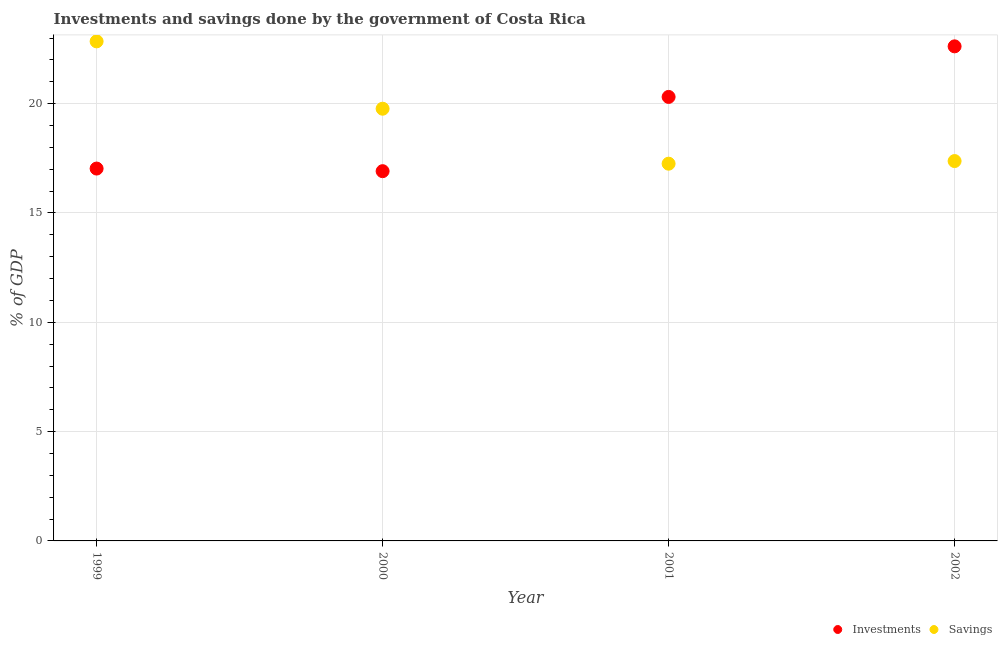How many different coloured dotlines are there?
Your response must be concise. 2. What is the investments of government in 2001?
Your answer should be very brief. 20.31. Across all years, what is the maximum investments of government?
Make the answer very short. 22.62. Across all years, what is the minimum savings of government?
Offer a very short reply. 17.25. In which year was the savings of government maximum?
Provide a short and direct response. 1999. In which year was the investments of government minimum?
Your answer should be very brief. 2000. What is the total investments of government in the graph?
Offer a very short reply. 76.87. What is the difference between the investments of government in 2000 and that in 2002?
Keep it short and to the point. -5.71. What is the difference between the investments of government in 2002 and the savings of government in 2000?
Offer a terse response. 2.85. What is the average investments of government per year?
Provide a short and direct response. 19.22. In the year 2001, what is the difference between the investments of government and savings of government?
Your response must be concise. 3.05. What is the ratio of the savings of government in 1999 to that in 2002?
Provide a short and direct response. 1.32. Is the difference between the investments of government in 1999 and 2001 greater than the difference between the savings of government in 1999 and 2001?
Your response must be concise. No. What is the difference between the highest and the second highest investments of government?
Offer a terse response. 2.31. What is the difference between the highest and the lowest savings of government?
Provide a short and direct response. 5.6. In how many years, is the savings of government greater than the average savings of government taken over all years?
Make the answer very short. 2. Is the sum of the investments of government in 1999 and 2002 greater than the maximum savings of government across all years?
Keep it short and to the point. Yes. Is the savings of government strictly greater than the investments of government over the years?
Provide a short and direct response. No. Is the savings of government strictly less than the investments of government over the years?
Your response must be concise. No. How many years are there in the graph?
Ensure brevity in your answer.  4. What is the difference between two consecutive major ticks on the Y-axis?
Your answer should be very brief. 5. Does the graph contain any zero values?
Your answer should be very brief. No. Does the graph contain grids?
Offer a very short reply. Yes. What is the title of the graph?
Offer a very short reply. Investments and savings done by the government of Costa Rica. Does "Nonresident" appear as one of the legend labels in the graph?
Give a very brief answer. No. What is the label or title of the Y-axis?
Provide a short and direct response. % of GDP. What is the % of GDP of Investments in 1999?
Offer a very short reply. 17.03. What is the % of GDP in Savings in 1999?
Offer a very short reply. 22.85. What is the % of GDP in Investments in 2000?
Provide a short and direct response. 16.91. What is the % of GDP in Savings in 2000?
Your response must be concise. 19.77. What is the % of GDP of Investments in 2001?
Offer a very short reply. 20.31. What is the % of GDP in Savings in 2001?
Provide a short and direct response. 17.25. What is the % of GDP of Investments in 2002?
Make the answer very short. 22.62. What is the % of GDP of Savings in 2002?
Ensure brevity in your answer.  17.37. Across all years, what is the maximum % of GDP in Investments?
Ensure brevity in your answer.  22.62. Across all years, what is the maximum % of GDP of Savings?
Your answer should be very brief. 22.85. Across all years, what is the minimum % of GDP of Investments?
Give a very brief answer. 16.91. Across all years, what is the minimum % of GDP in Savings?
Your answer should be compact. 17.25. What is the total % of GDP of Investments in the graph?
Your answer should be very brief. 76.87. What is the total % of GDP of Savings in the graph?
Your response must be concise. 77.25. What is the difference between the % of GDP in Investments in 1999 and that in 2000?
Provide a short and direct response. 0.12. What is the difference between the % of GDP of Savings in 1999 and that in 2000?
Offer a terse response. 3.08. What is the difference between the % of GDP of Investments in 1999 and that in 2001?
Your response must be concise. -3.28. What is the difference between the % of GDP in Savings in 1999 and that in 2001?
Provide a succinct answer. 5.59. What is the difference between the % of GDP of Investments in 1999 and that in 2002?
Provide a short and direct response. -5.59. What is the difference between the % of GDP in Savings in 1999 and that in 2002?
Make the answer very short. 5.47. What is the difference between the % of GDP in Investments in 2000 and that in 2001?
Give a very brief answer. -3.4. What is the difference between the % of GDP in Savings in 2000 and that in 2001?
Your answer should be very brief. 2.51. What is the difference between the % of GDP in Investments in 2000 and that in 2002?
Offer a very short reply. -5.71. What is the difference between the % of GDP in Savings in 2000 and that in 2002?
Provide a short and direct response. 2.39. What is the difference between the % of GDP of Investments in 2001 and that in 2002?
Offer a terse response. -2.31. What is the difference between the % of GDP in Savings in 2001 and that in 2002?
Offer a terse response. -0.12. What is the difference between the % of GDP in Investments in 1999 and the % of GDP in Savings in 2000?
Your answer should be compact. -2.74. What is the difference between the % of GDP in Investments in 1999 and the % of GDP in Savings in 2001?
Keep it short and to the point. -0.22. What is the difference between the % of GDP in Investments in 1999 and the % of GDP in Savings in 2002?
Your response must be concise. -0.34. What is the difference between the % of GDP in Investments in 2000 and the % of GDP in Savings in 2001?
Your answer should be very brief. -0.34. What is the difference between the % of GDP in Investments in 2000 and the % of GDP in Savings in 2002?
Offer a terse response. -0.46. What is the difference between the % of GDP in Investments in 2001 and the % of GDP in Savings in 2002?
Provide a succinct answer. 2.93. What is the average % of GDP in Investments per year?
Your response must be concise. 19.22. What is the average % of GDP in Savings per year?
Your answer should be very brief. 19.31. In the year 1999, what is the difference between the % of GDP in Investments and % of GDP in Savings?
Make the answer very short. -5.82. In the year 2000, what is the difference between the % of GDP in Investments and % of GDP in Savings?
Provide a short and direct response. -2.86. In the year 2001, what is the difference between the % of GDP in Investments and % of GDP in Savings?
Ensure brevity in your answer.  3.05. In the year 2002, what is the difference between the % of GDP of Investments and % of GDP of Savings?
Provide a short and direct response. 5.25. What is the ratio of the % of GDP in Investments in 1999 to that in 2000?
Keep it short and to the point. 1.01. What is the ratio of the % of GDP of Savings in 1999 to that in 2000?
Your answer should be compact. 1.16. What is the ratio of the % of GDP in Investments in 1999 to that in 2001?
Give a very brief answer. 0.84. What is the ratio of the % of GDP of Savings in 1999 to that in 2001?
Your answer should be very brief. 1.32. What is the ratio of the % of GDP in Investments in 1999 to that in 2002?
Your response must be concise. 0.75. What is the ratio of the % of GDP of Savings in 1999 to that in 2002?
Provide a succinct answer. 1.32. What is the ratio of the % of GDP in Investments in 2000 to that in 2001?
Offer a terse response. 0.83. What is the ratio of the % of GDP of Savings in 2000 to that in 2001?
Provide a short and direct response. 1.15. What is the ratio of the % of GDP of Investments in 2000 to that in 2002?
Your answer should be very brief. 0.75. What is the ratio of the % of GDP of Savings in 2000 to that in 2002?
Your answer should be compact. 1.14. What is the ratio of the % of GDP in Investments in 2001 to that in 2002?
Give a very brief answer. 0.9. What is the ratio of the % of GDP in Savings in 2001 to that in 2002?
Keep it short and to the point. 0.99. What is the difference between the highest and the second highest % of GDP in Investments?
Offer a very short reply. 2.31. What is the difference between the highest and the second highest % of GDP of Savings?
Provide a succinct answer. 3.08. What is the difference between the highest and the lowest % of GDP in Investments?
Offer a terse response. 5.71. What is the difference between the highest and the lowest % of GDP of Savings?
Provide a short and direct response. 5.59. 